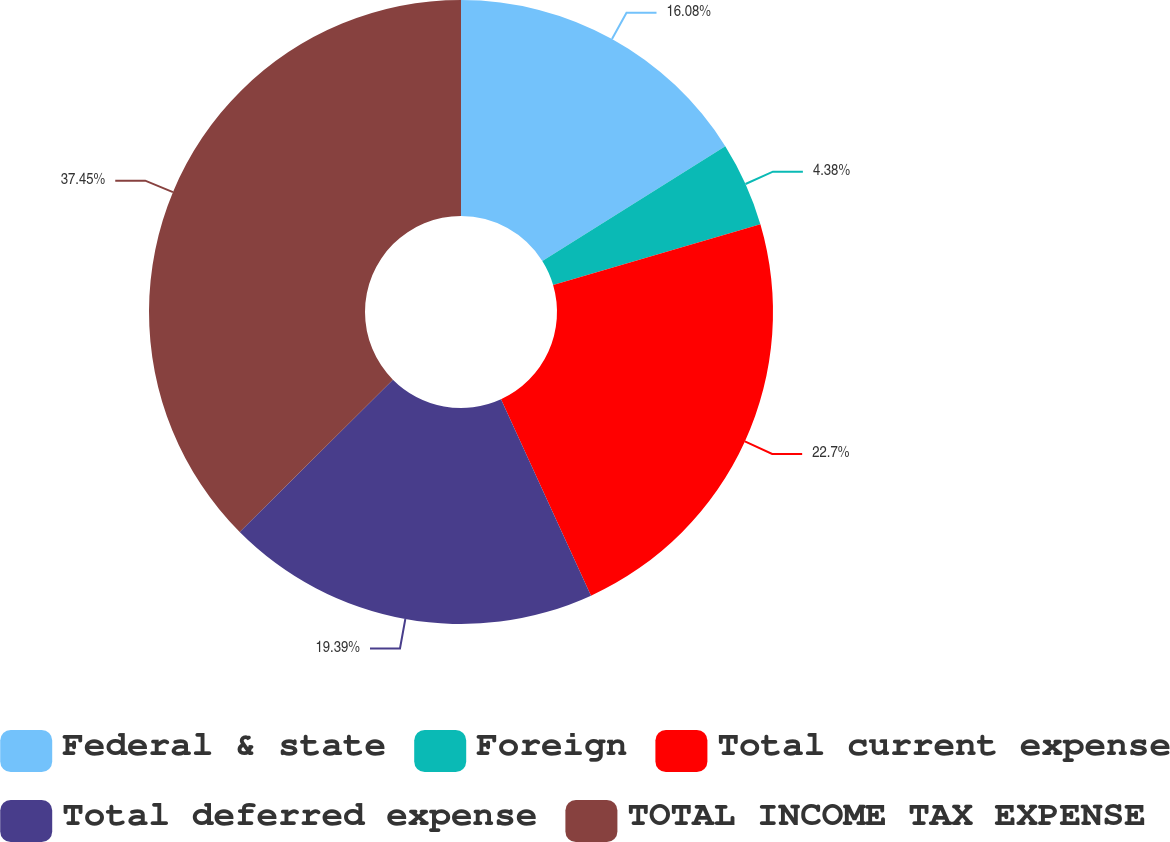<chart> <loc_0><loc_0><loc_500><loc_500><pie_chart><fcel>Federal & state<fcel>Foreign<fcel>Total current expense<fcel>Total deferred expense<fcel>TOTAL INCOME TAX EXPENSE<nl><fcel>16.08%<fcel>4.38%<fcel>22.7%<fcel>19.39%<fcel>37.45%<nl></chart> 